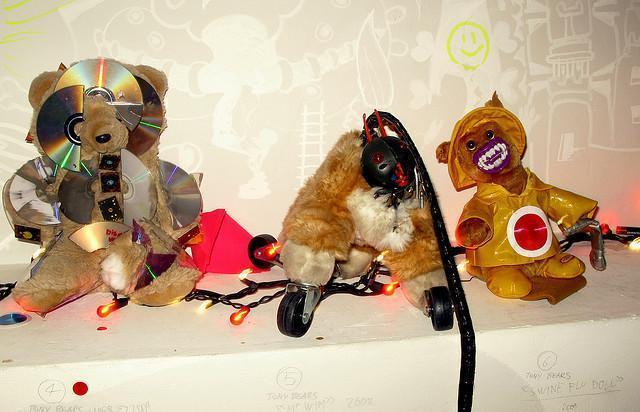How many teddy bears are there?
Give a very brief answer. 3. 